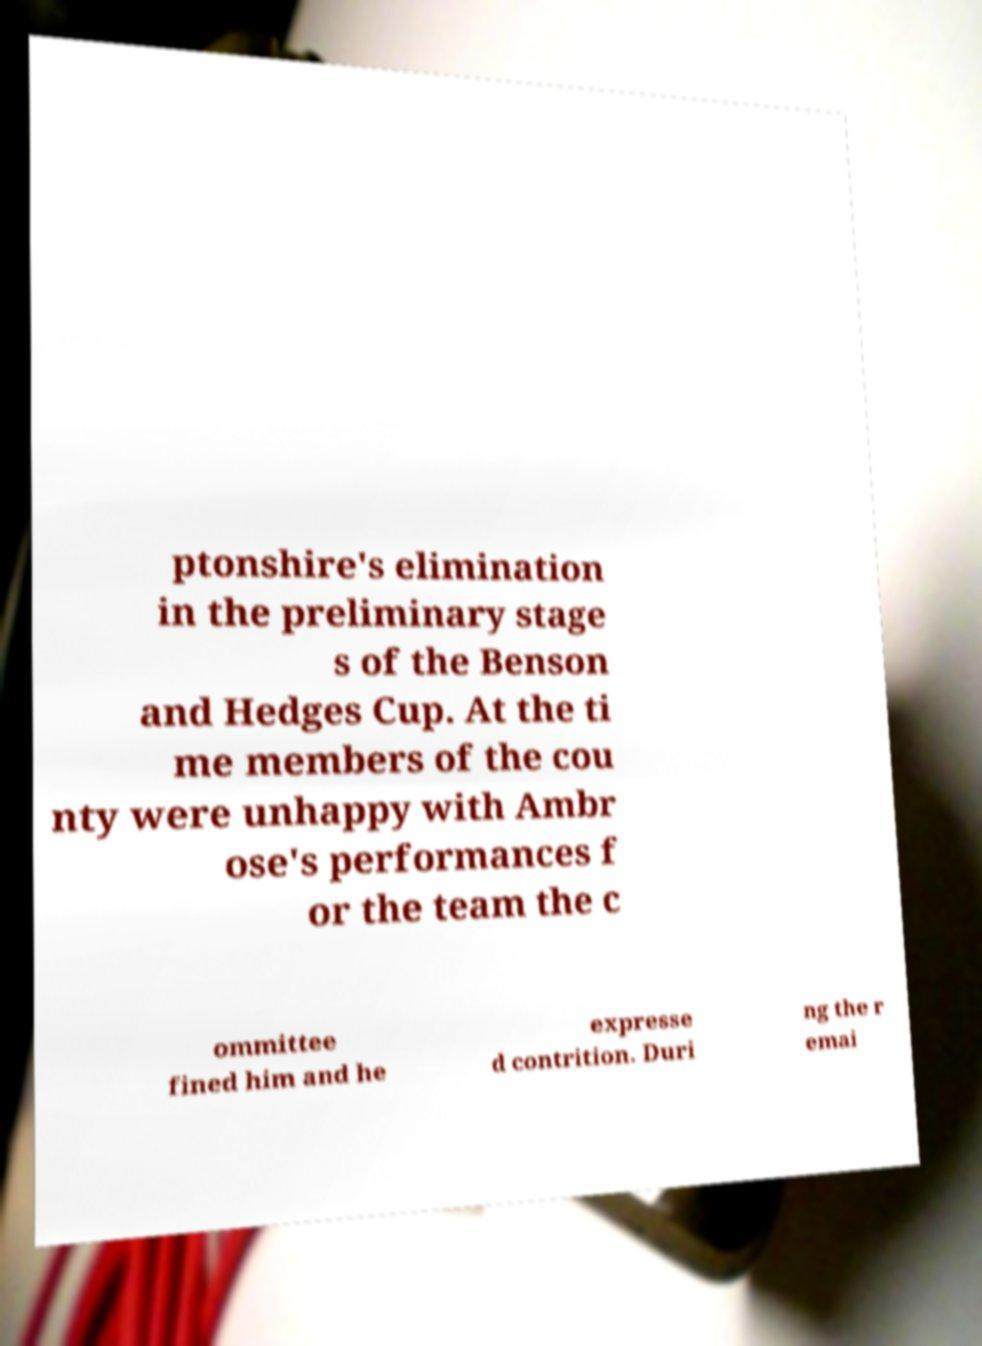For documentation purposes, I need the text within this image transcribed. Could you provide that? ptonshire's elimination in the preliminary stage s of the Benson and Hedges Cup. At the ti me members of the cou nty were unhappy with Ambr ose's performances f or the team the c ommittee fined him and he expresse d contrition. Duri ng the r emai 